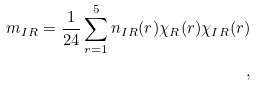<formula> <loc_0><loc_0><loc_500><loc_500>m _ { I R } = \frac { 1 } { 2 4 } \sum _ { r = 1 } ^ { 5 } n _ { I R } ( r ) \chi _ { R } ( r ) \chi _ { I R } ( r ) \\ ,</formula> 